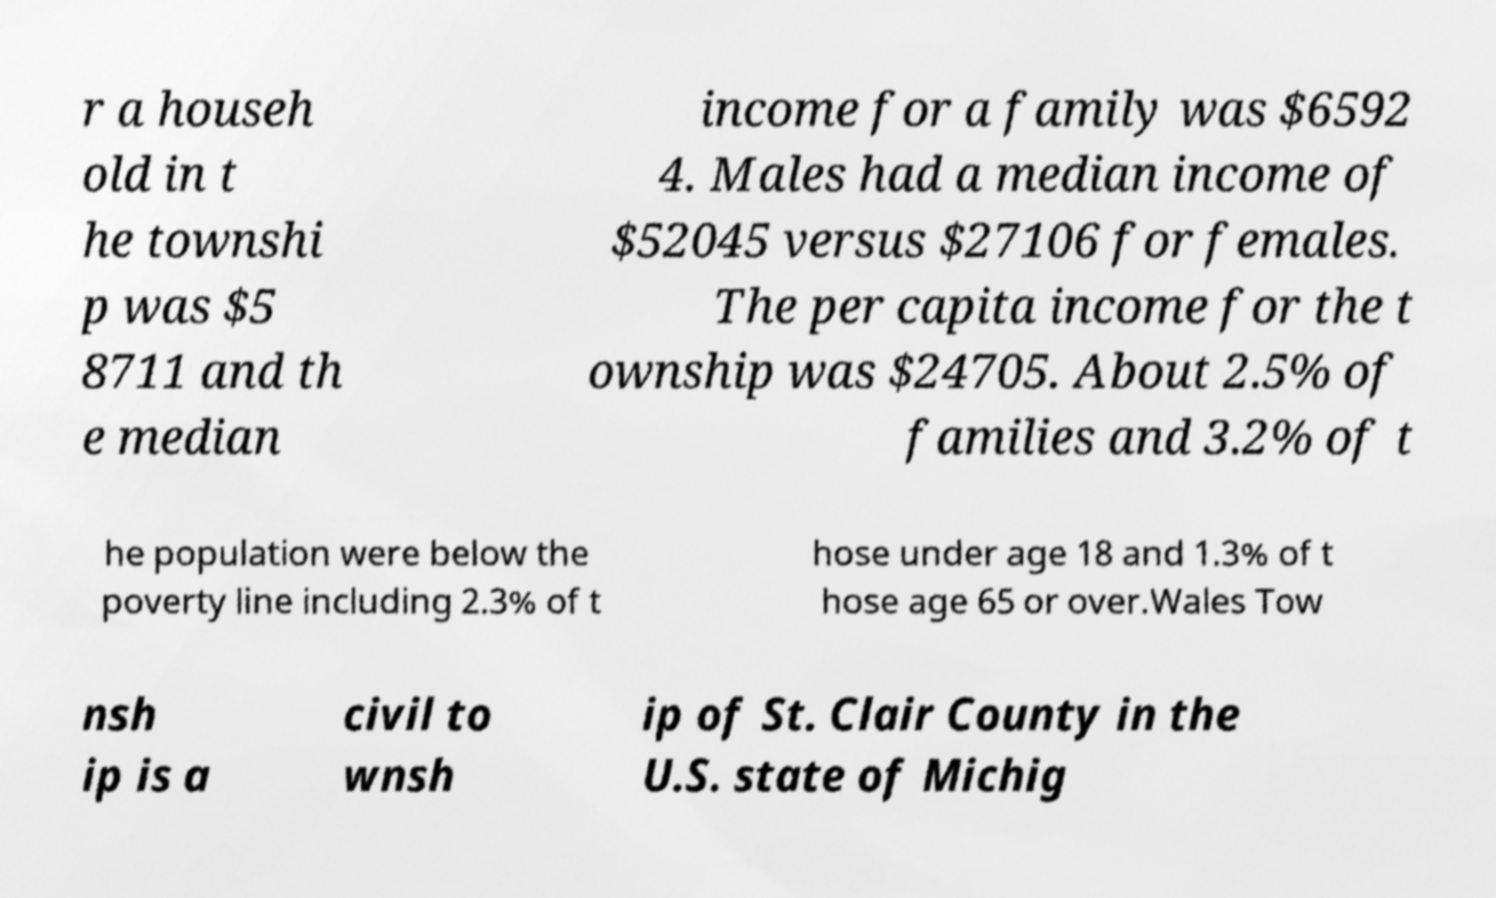Please identify and transcribe the text found in this image. r a househ old in t he townshi p was $5 8711 and th e median income for a family was $6592 4. Males had a median income of $52045 versus $27106 for females. The per capita income for the t ownship was $24705. About 2.5% of families and 3.2% of t he population were below the poverty line including 2.3% of t hose under age 18 and 1.3% of t hose age 65 or over.Wales Tow nsh ip is a civil to wnsh ip of St. Clair County in the U.S. state of Michig 